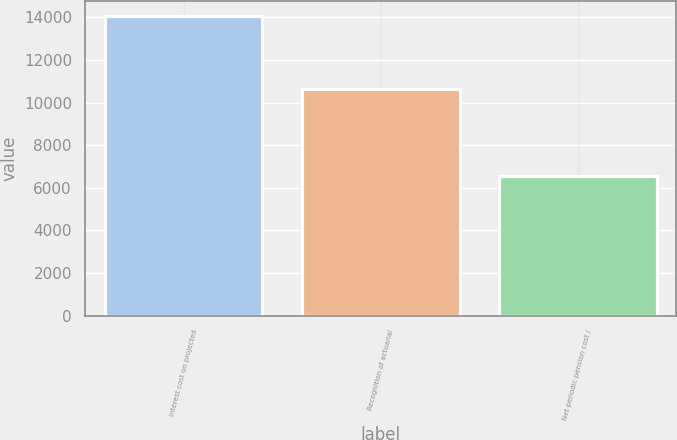Convert chart. <chart><loc_0><loc_0><loc_500><loc_500><bar_chart><fcel>Interest cost on projected<fcel>Recognition of actuarial<fcel>Net periodic pension cost /<nl><fcel>14071<fcel>10639<fcel>6542<nl></chart> 